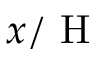<formula> <loc_0><loc_0><loc_500><loc_500>x / H</formula> 